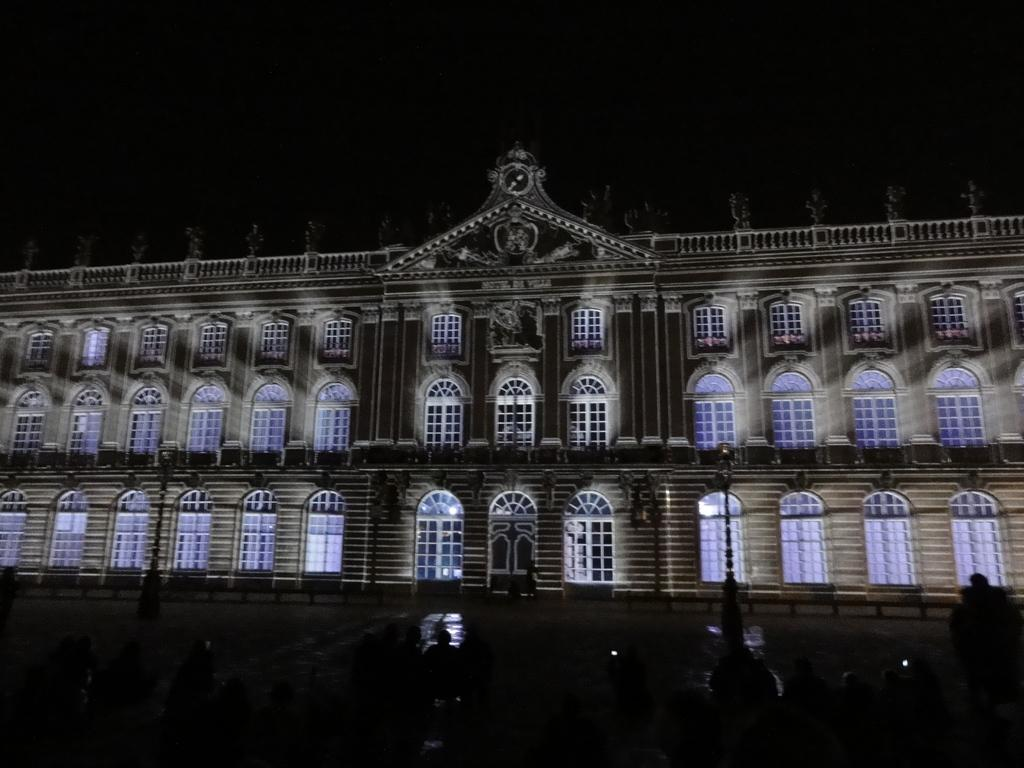What is the main structure in the picture? There is a building in the picture. What feature can be seen on the building? The building has windows. What other object is present in the picture? There is a pole in the picture. How many flies can be seen on the building in the image? There are no flies visible in the image. What type of locket is hanging from the pole in the image? There is no locket present in the image. 